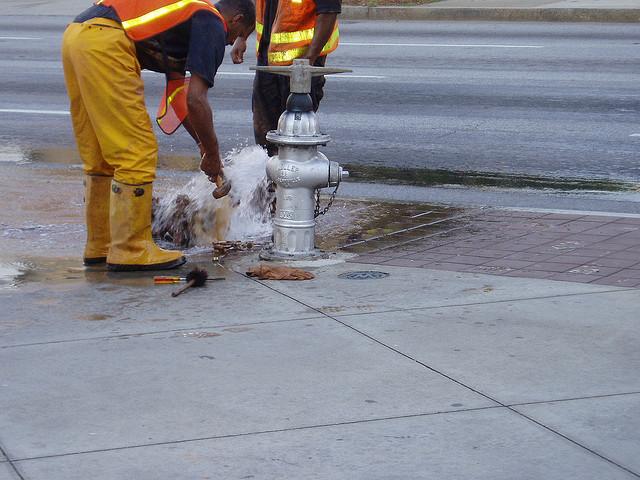Where is the manhole cover on the street?
Write a very short answer. By hydrant. Are the subjects feet on the ground?
Short answer required. Yes. What color is his vest?
Answer briefly. Orange. How many people in the picture?
Give a very brief answer. 2. Is this man a firefighter?
Answer briefly. No. Where is the water coming from?
Be succinct. Fire hydrant. Which man is wearing rubber boots?
Short answer required. Left. 